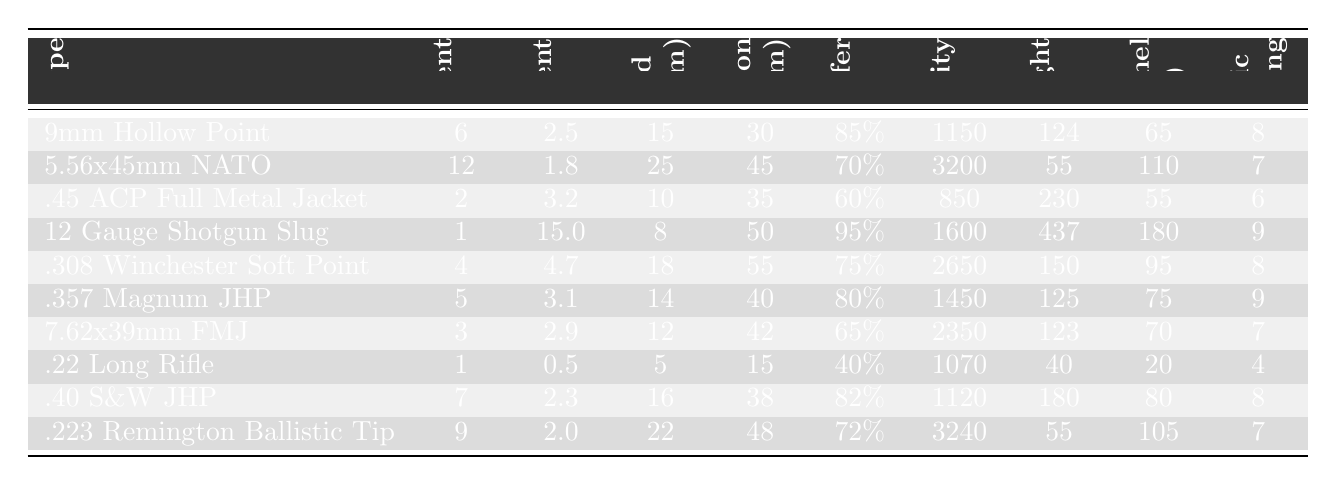What is the average fragment count for the 9mm Hollow Point? The table shows that the average fragment count for the 9mm Hollow Point is provided directly in the corresponding row. It states an average of 6.
Answer: 6 Which ammunition type has the highest average fragment size? By examining the "Avg. Fragment Size (mm)" column, the largest value can be found under the 12 Gauge Shotgun Slug with an average size of 15.0 mm.
Answer: 12 Gauge Shotgun Slug What is the maximum spread diameter of the .40 S&W Jacketed Hollow Point? The "Max Spread Diameter (cm)" column shows that for the .40 S&W Jacketed Hollow Point, the maximum spread diameter is 16 cm.
Answer: 16 cm Which ammunition type has the highest penetration depth? Looking at the "Penetration Depth (cm)" column, the .308 Winchester Soft Point has the highest penetration depth at 55 cm.
Answer: .308 Winchester Soft Point Is the energy transfer percentage for the 5.56x45mm NATO greater than 75%? By checking the "Energy Transfer Percentage" column for the 5.56x45mm NATO, it shows 70%, which is less than 75%.
Answer: No What is the average wound channel volume for the ammunition types that have a terminal ballistic performance rating of 9? The ammunition types with a rating of 9 are the 12 Gauge Shotgun Slug and .357 Magnum JHP, with wound channel volumes of 180 cc and 75 cc respectively. The average is (180 + 75) / 2 = 127.5 cc.
Answer: 127.5 cc How does the typical muzzle velocity of .223 Remington Ballistic Tip compare to that of .45 ACP Full Metal Jacket? The muzzle velocity of the .223 Remington Ballistic Tip is 3240 fps while the .45 ACP Full Metal Jacket is 850 fps. The difference is 3240 - 850 = 2390 fps, meaning .223 is significantly higher.
Answer: 2390 fps Which ammunition type has the lowest bullet weight and what is that weight? The table indicates that the .22 Long Rifle has the lowest bullet weight listed at 40 grains.
Answer: .22 Long Rifle, 40 grains What is the total energy transfer percentage of the two ammunition types with the highest average fragment count? The two types with the highest average fragment counts are the 5.56x45mm NATO (70%) and 9mm Hollow Point (85%). The sum of their percentages is 70 + 85 = 155%.
Answer: 155% Which two ammunition types provide the highest average energy transfer percentage, and what are those percentages? The highest percentages are from the 12 Gauge Shotgun Slug (95%) and the .40 S&W Jacketed Hollow Point (82%). These are the top two based on values from the table.
Answer: 12 Gauge Shotgun Slug (95%), .40 S&W JHP (82%) 